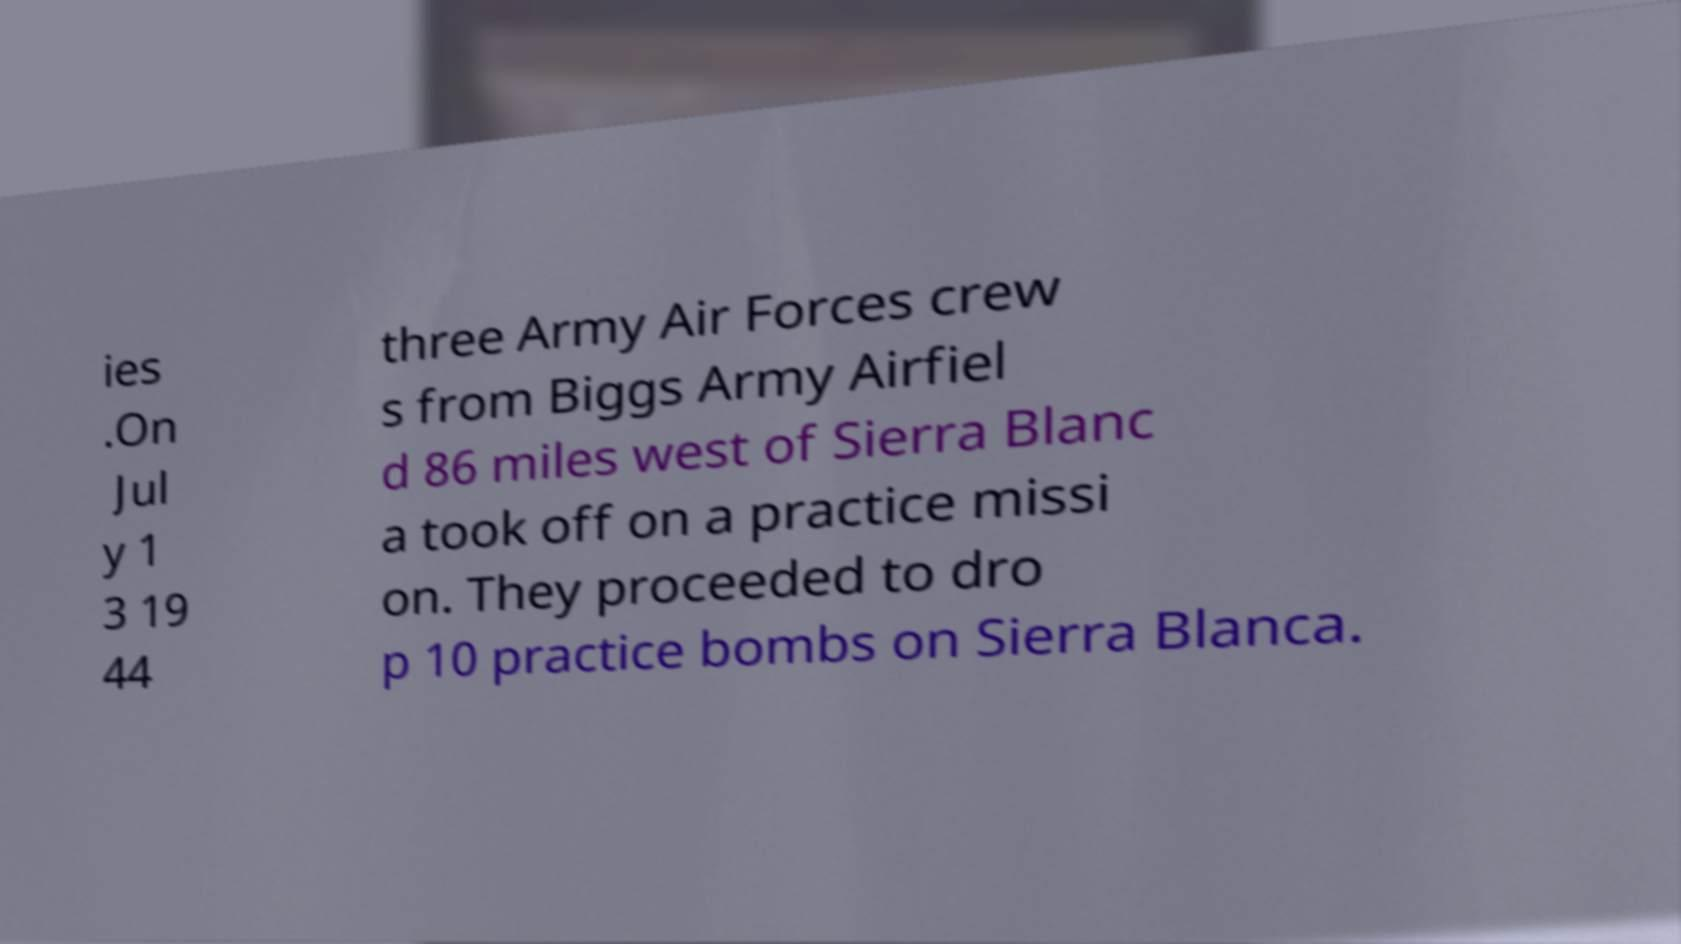What messages or text are displayed in this image? I need them in a readable, typed format. ies .On Jul y 1 3 19 44 three Army Air Forces crew s from Biggs Army Airfiel d 86 miles west of Sierra Blanc a took off on a practice missi on. They proceeded to dro p 10 practice bombs on Sierra Blanca. 